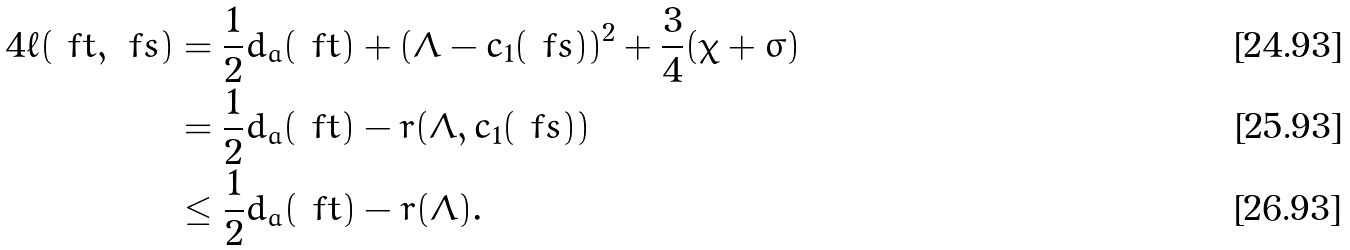<formula> <loc_0><loc_0><loc_500><loc_500>4 \ell ( \ f t , \ f s ) & = \frac { 1 } { 2 } d _ { a } ( \ f t ) + ( \Lambda - c _ { 1 } ( \ f s ) ) ^ { 2 } + \frac { 3 } { 4 } ( \chi + \sigma ) \\ & = \frac { 1 } { 2 } d _ { a } ( \ f t ) - r ( \Lambda , c _ { 1 } ( \ f s ) ) \\ & \leq \frac { 1 } { 2 } d _ { a } ( \ f t ) - r ( \Lambda ) .</formula> 